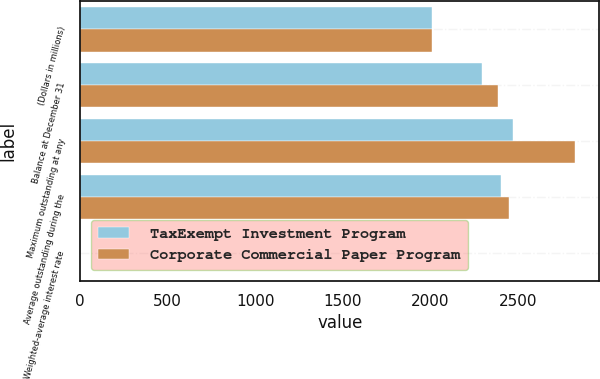Convert chart to OTSL. <chart><loc_0><loc_0><loc_500><loc_500><stacked_bar_chart><ecel><fcel>(Dollars in millions)<fcel>Balance at December 31<fcel>Maximum outstanding at any<fcel>Average outstanding during the<fcel>Weighted-average interest rate<nl><fcel>TaxExempt Investment Program<fcel>2011<fcel>2294<fcel>2473<fcel>2404<fcel>0.26<nl><fcel>Corporate Commercial Paper Program<fcel>2011<fcel>2384<fcel>2825<fcel>2449<fcel>0.23<nl></chart> 